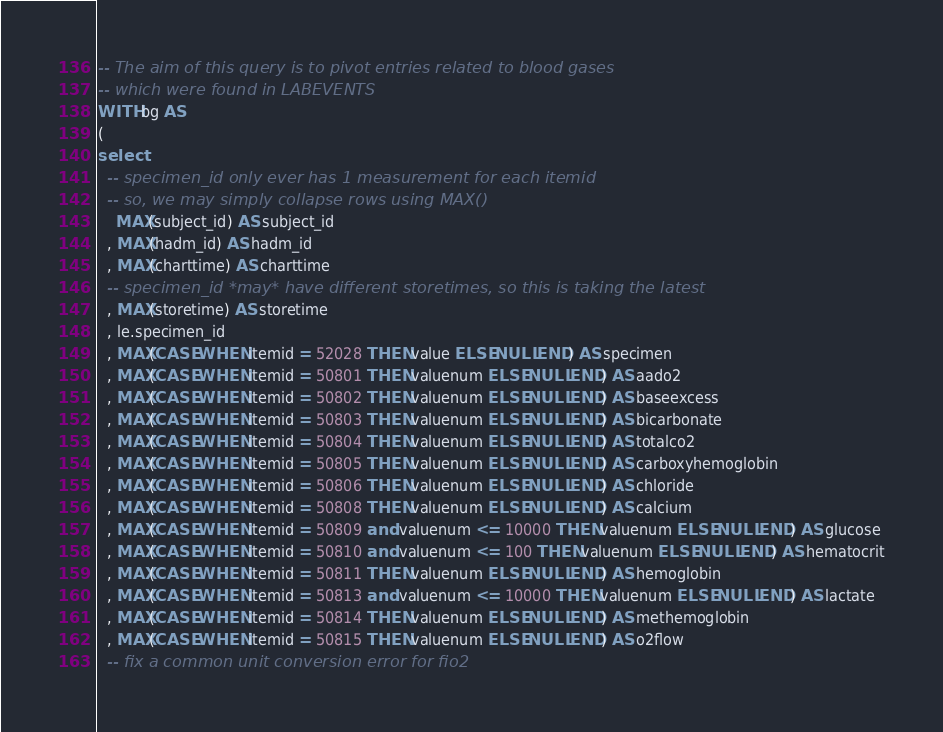<code> <loc_0><loc_0><loc_500><loc_500><_SQL_>-- The aim of this query is to pivot entries related to blood gases
-- which were found in LABEVENTS
WITH bg AS
(
select
  -- specimen_id only ever has 1 measurement for each itemid
  -- so, we may simply collapse rows using MAX()
    MAX(subject_id) AS subject_id
  , MAX(hadm_id) AS hadm_id
  , MAX(charttime) AS charttime
  -- specimen_id *may* have different storetimes, so this is taking the latest
  , MAX(storetime) AS storetime
  , le.specimen_id
  , MAX(CASE WHEN itemid = 52028 THEN value ELSE NULL END) AS specimen
  , MAX(CASE WHEN itemid = 50801 THEN valuenum ELSE NULL END) AS aado2
  , MAX(CASE WHEN itemid = 50802 THEN valuenum ELSE NULL END) AS baseexcess
  , MAX(CASE WHEN itemid = 50803 THEN valuenum ELSE NULL END) AS bicarbonate
  , MAX(CASE WHEN itemid = 50804 THEN valuenum ELSE NULL END) AS totalco2
  , MAX(CASE WHEN itemid = 50805 THEN valuenum ELSE NULL END) AS carboxyhemoglobin
  , MAX(CASE WHEN itemid = 50806 THEN valuenum ELSE NULL END) AS chloride
  , MAX(CASE WHEN itemid = 50808 THEN valuenum ELSE NULL END) AS calcium
  , MAX(CASE WHEN itemid = 50809 and valuenum <= 10000 THEN valuenum ELSE NULL END) AS glucose
  , MAX(CASE WHEN itemid = 50810 and valuenum <= 100 THEN valuenum ELSE NULL END) AS hematocrit
  , MAX(CASE WHEN itemid = 50811 THEN valuenum ELSE NULL END) AS hemoglobin
  , MAX(CASE WHEN itemid = 50813 and valuenum <= 10000 THEN valuenum ELSE NULL END) AS lactate
  , MAX(CASE WHEN itemid = 50814 THEN valuenum ELSE NULL END) AS methemoglobin
  , MAX(CASE WHEN itemid = 50815 THEN valuenum ELSE NULL END) AS o2flow
  -- fix a common unit conversion error for fio2</code> 